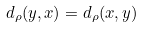<formula> <loc_0><loc_0><loc_500><loc_500>d _ { \rho } ( y , x ) = d _ { \rho } ( x , y )</formula> 